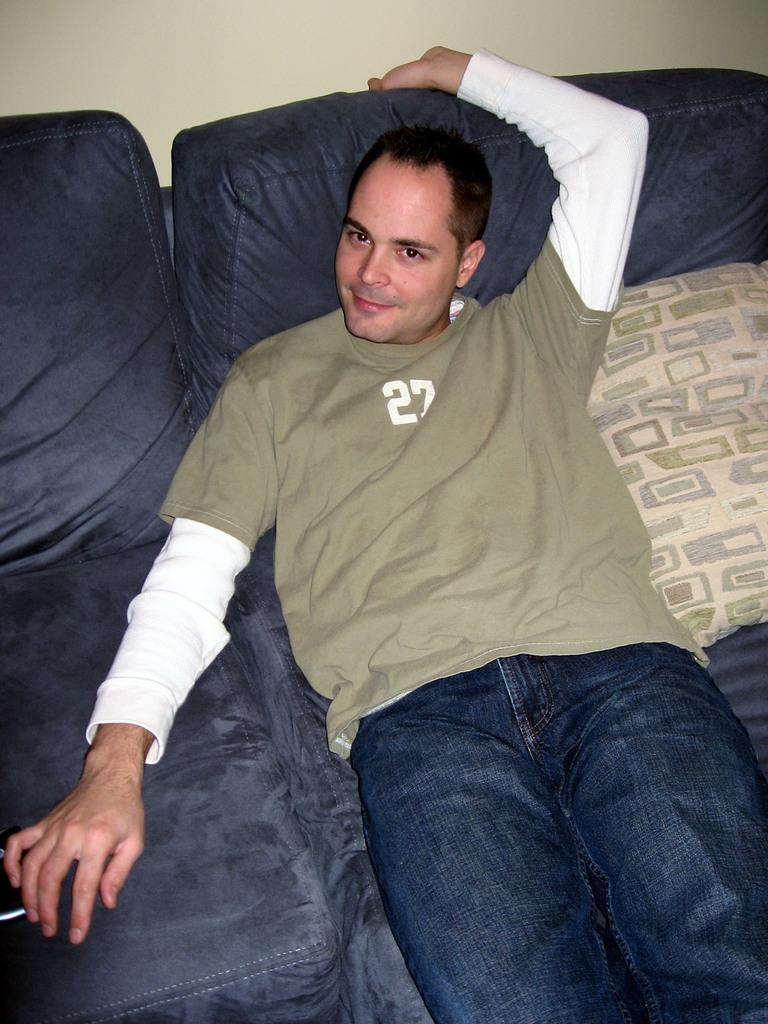What is the person in the image doing? There is a person lying on a bed in the image. What type of furniture is present in the image? Cushions are present in the image. What can be seen in the background of the image? There is a wall visible in the image. Where might this image have been taken? The image is likely taken in a room. What shape is the worm in the image? There is no worm present in the image. 